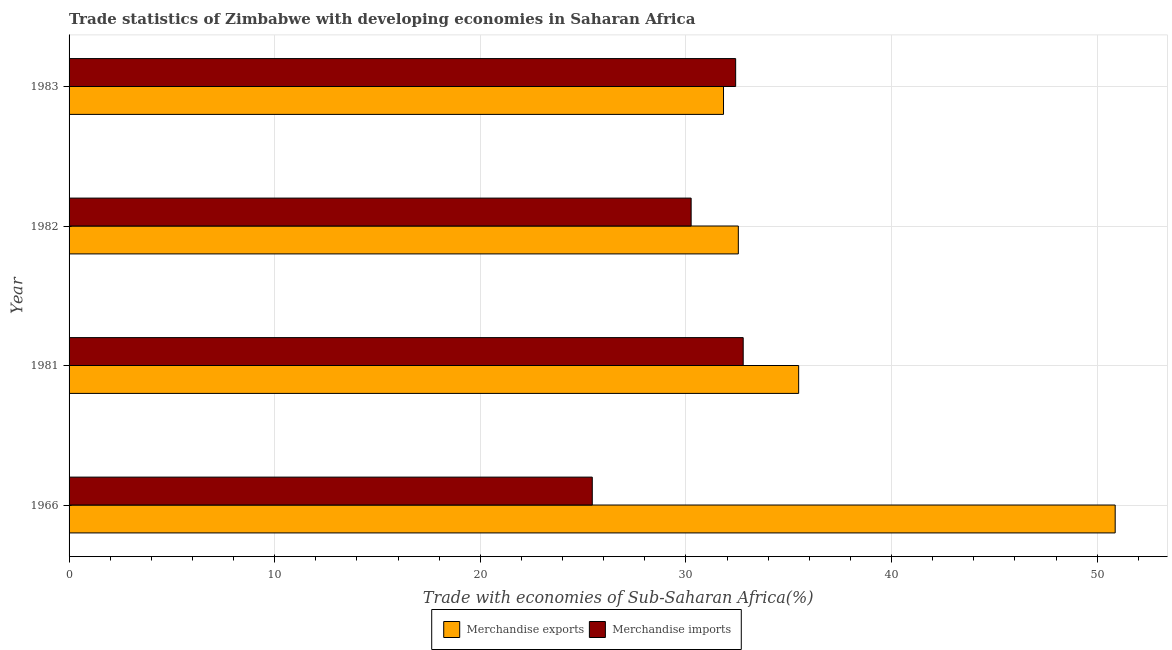How many different coloured bars are there?
Ensure brevity in your answer.  2. Are the number of bars per tick equal to the number of legend labels?
Provide a succinct answer. Yes. Are the number of bars on each tick of the Y-axis equal?
Offer a very short reply. Yes. How many bars are there on the 1st tick from the top?
Provide a succinct answer. 2. How many bars are there on the 1st tick from the bottom?
Offer a terse response. 2. What is the label of the 3rd group of bars from the top?
Give a very brief answer. 1981. In how many cases, is the number of bars for a given year not equal to the number of legend labels?
Your response must be concise. 0. What is the merchandise exports in 1981?
Make the answer very short. 35.48. Across all years, what is the maximum merchandise imports?
Keep it short and to the point. 32.78. Across all years, what is the minimum merchandise exports?
Offer a terse response. 31.83. In which year was the merchandise exports maximum?
Provide a short and direct response. 1966. In which year was the merchandise imports minimum?
Provide a short and direct response. 1966. What is the total merchandise exports in the graph?
Your answer should be very brief. 150.73. What is the difference between the merchandise exports in 1966 and that in 1983?
Your response must be concise. 19.05. What is the difference between the merchandise imports in 1966 and the merchandise exports in 1982?
Provide a succinct answer. -7.1. What is the average merchandise imports per year?
Provide a succinct answer. 30.22. In the year 1982, what is the difference between the merchandise exports and merchandise imports?
Make the answer very short. 2.29. What is the ratio of the merchandise exports in 1966 to that in 1983?
Your response must be concise. 1.6. What is the difference between the highest and the second highest merchandise imports?
Provide a succinct answer. 0.37. What is the difference between the highest and the lowest merchandise imports?
Your answer should be very brief. 7.34. Is the sum of the merchandise imports in 1966 and 1983 greater than the maximum merchandise exports across all years?
Provide a short and direct response. Yes. What does the 1st bar from the top in 1982 represents?
Your response must be concise. Merchandise imports. What does the 1st bar from the bottom in 1982 represents?
Offer a terse response. Merchandise exports. How many years are there in the graph?
Provide a succinct answer. 4. Does the graph contain any zero values?
Make the answer very short. No. How many legend labels are there?
Keep it short and to the point. 2. How are the legend labels stacked?
Provide a short and direct response. Horizontal. What is the title of the graph?
Your answer should be very brief. Trade statistics of Zimbabwe with developing economies in Saharan Africa. Does "Lowest 10% of population" appear as one of the legend labels in the graph?
Give a very brief answer. No. What is the label or title of the X-axis?
Make the answer very short. Trade with economies of Sub-Saharan Africa(%). What is the label or title of the Y-axis?
Provide a succinct answer. Year. What is the Trade with economies of Sub-Saharan Africa(%) in Merchandise exports in 1966?
Offer a very short reply. 50.87. What is the Trade with economies of Sub-Saharan Africa(%) in Merchandise imports in 1966?
Make the answer very short. 25.44. What is the Trade with economies of Sub-Saharan Africa(%) of Merchandise exports in 1981?
Offer a terse response. 35.48. What is the Trade with economies of Sub-Saharan Africa(%) of Merchandise imports in 1981?
Offer a very short reply. 32.78. What is the Trade with economies of Sub-Saharan Africa(%) of Merchandise exports in 1982?
Make the answer very short. 32.55. What is the Trade with economies of Sub-Saharan Africa(%) of Merchandise imports in 1982?
Your response must be concise. 30.25. What is the Trade with economies of Sub-Saharan Africa(%) of Merchandise exports in 1983?
Give a very brief answer. 31.83. What is the Trade with economies of Sub-Saharan Africa(%) of Merchandise imports in 1983?
Ensure brevity in your answer.  32.42. Across all years, what is the maximum Trade with economies of Sub-Saharan Africa(%) of Merchandise exports?
Offer a terse response. 50.87. Across all years, what is the maximum Trade with economies of Sub-Saharan Africa(%) of Merchandise imports?
Provide a short and direct response. 32.78. Across all years, what is the minimum Trade with economies of Sub-Saharan Africa(%) of Merchandise exports?
Provide a short and direct response. 31.83. Across all years, what is the minimum Trade with economies of Sub-Saharan Africa(%) in Merchandise imports?
Offer a very short reply. 25.44. What is the total Trade with economies of Sub-Saharan Africa(%) in Merchandise exports in the graph?
Offer a terse response. 150.73. What is the total Trade with economies of Sub-Saharan Africa(%) in Merchandise imports in the graph?
Your answer should be very brief. 120.89. What is the difference between the Trade with economies of Sub-Saharan Africa(%) in Merchandise exports in 1966 and that in 1981?
Provide a succinct answer. 15.39. What is the difference between the Trade with economies of Sub-Saharan Africa(%) of Merchandise imports in 1966 and that in 1981?
Provide a succinct answer. -7.34. What is the difference between the Trade with economies of Sub-Saharan Africa(%) in Merchandise exports in 1966 and that in 1982?
Provide a short and direct response. 18.33. What is the difference between the Trade with economies of Sub-Saharan Africa(%) of Merchandise imports in 1966 and that in 1982?
Offer a very short reply. -4.81. What is the difference between the Trade with economies of Sub-Saharan Africa(%) in Merchandise exports in 1966 and that in 1983?
Offer a very short reply. 19.05. What is the difference between the Trade with economies of Sub-Saharan Africa(%) in Merchandise imports in 1966 and that in 1983?
Your response must be concise. -6.97. What is the difference between the Trade with economies of Sub-Saharan Africa(%) of Merchandise exports in 1981 and that in 1982?
Give a very brief answer. 2.93. What is the difference between the Trade with economies of Sub-Saharan Africa(%) in Merchandise imports in 1981 and that in 1982?
Offer a very short reply. 2.53. What is the difference between the Trade with economies of Sub-Saharan Africa(%) of Merchandise exports in 1981 and that in 1983?
Provide a succinct answer. 3.65. What is the difference between the Trade with economies of Sub-Saharan Africa(%) in Merchandise imports in 1981 and that in 1983?
Provide a succinct answer. 0.37. What is the difference between the Trade with economies of Sub-Saharan Africa(%) in Merchandise exports in 1982 and that in 1983?
Offer a very short reply. 0.72. What is the difference between the Trade with economies of Sub-Saharan Africa(%) of Merchandise imports in 1982 and that in 1983?
Provide a short and direct response. -2.16. What is the difference between the Trade with economies of Sub-Saharan Africa(%) in Merchandise exports in 1966 and the Trade with economies of Sub-Saharan Africa(%) in Merchandise imports in 1981?
Provide a succinct answer. 18.09. What is the difference between the Trade with economies of Sub-Saharan Africa(%) in Merchandise exports in 1966 and the Trade with economies of Sub-Saharan Africa(%) in Merchandise imports in 1982?
Offer a terse response. 20.62. What is the difference between the Trade with economies of Sub-Saharan Africa(%) in Merchandise exports in 1966 and the Trade with economies of Sub-Saharan Africa(%) in Merchandise imports in 1983?
Provide a succinct answer. 18.46. What is the difference between the Trade with economies of Sub-Saharan Africa(%) of Merchandise exports in 1981 and the Trade with economies of Sub-Saharan Africa(%) of Merchandise imports in 1982?
Offer a terse response. 5.23. What is the difference between the Trade with economies of Sub-Saharan Africa(%) of Merchandise exports in 1981 and the Trade with economies of Sub-Saharan Africa(%) of Merchandise imports in 1983?
Your answer should be compact. 3.06. What is the difference between the Trade with economies of Sub-Saharan Africa(%) of Merchandise exports in 1982 and the Trade with economies of Sub-Saharan Africa(%) of Merchandise imports in 1983?
Keep it short and to the point. 0.13. What is the average Trade with economies of Sub-Saharan Africa(%) of Merchandise exports per year?
Your response must be concise. 37.68. What is the average Trade with economies of Sub-Saharan Africa(%) in Merchandise imports per year?
Ensure brevity in your answer.  30.22. In the year 1966, what is the difference between the Trade with economies of Sub-Saharan Africa(%) of Merchandise exports and Trade with economies of Sub-Saharan Africa(%) of Merchandise imports?
Provide a succinct answer. 25.43. In the year 1981, what is the difference between the Trade with economies of Sub-Saharan Africa(%) in Merchandise exports and Trade with economies of Sub-Saharan Africa(%) in Merchandise imports?
Provide a succinct answer. 2.7. In the year 1982, what is the difference between the Trade with economies of Sub-Saharan Africa(%) of Merchandise exports and Trade with economies of Sub-Saharan Africa(%) of Merchandise imports?
Your answer should be very brief. 2.3. In the year 1983, what is the difference between the Trade with economies of Sub-Saharan Africa(%) in Merchandise exports and Trade with economies of Sub-Saharan Africa(%) in Merchandise imports?
Give a very brief answer. -0.59. What is the ratio of the Trade with economies of Sub-Saharan Africa(%) of Merchandise exports in 1966 to that in 1981?
Your answer should be very brief. 1.43. What is the ratio of the Trade with economies of Sub-Saharan Africa(%) in Merchandise imports in 1966 to that in 1981?
Offer a terse response. 0.78. What is the ratio of the Trade with economies of Sub-Saharan Africa(%) of Merchandise exports in 1966 to that in 1982?
Your response must be concise. 1.56. What is the ratio of the Trade with economies of Sub-Saharan Africa(%) of Merchandise imports in 1966 to that in 1982?
Provide a short and direct response. 0.84. What is the ratio of the Trade with economies of Sub-Saharan Africa(%) in Merchandise exports in 1966 to that in 1983?
Ensure brevity in your answer.  1.6. What is the ratio of the Trade with economies of Sub-Saharan Africa(%) of Merchandise imports in 1966 to that in 1983?
Offer a very short reply. 0.78. What is the ratio of the Trade with economies of Sub-Saharan Africa(%) of Merchandise exports in 1981 to that in 1982?
Keep it short and to the point. 1.09. What is the ratio of the Trade with economies of Sub-Saharan Africa(%) in Merchandise imports in 1981 to that in 1982?
Provide a succinct answer. 1.08. What is the ratio of the Trade with economies of Sub-Saharan Africa(%) in Merchandise exports in 1981 to that in 1983?
Give a very brief answer. 1.11. What is the ratio of the Trade with economies of Sub-Saharan Africa(%) in Merchandise imports in 1981 to that in 1983?
Offer a terse response. 1.01. What is the ratio of the Trade with economies of Sub-Saharan Africa(%) in Merchandise exports in 1982 to that in 1983?
Offer a very short reply. 1.02. What is the ratio of the Trade with economies of Sub-Saharan Africa(%) of Merchandise imports in 1982 to that in 1983?
Keep it short and to the point. 0.93. What is the difference between the highest and the second highest Trade with economies of Sub-Saharan Africa(%) in Merchandise exports?
Ensure brevity in your answer.  15.39. What is the difference between the highest and the second highest Trade with economies of Sub-Saharan Africa(%) of Merchandise imports?
Your answer should be compact. 0.37. What is the difference between the highest and the lowest Trade with economies of Sub-Saharan Africa(%) in Merchandise exports?
Your response must be concise. 19.05. What is the difference between the highest and the lowest Trade with economies of Sub-Saharan Africa(%) in Merchandise imports?
Provide a succinct answer. 7.34. 